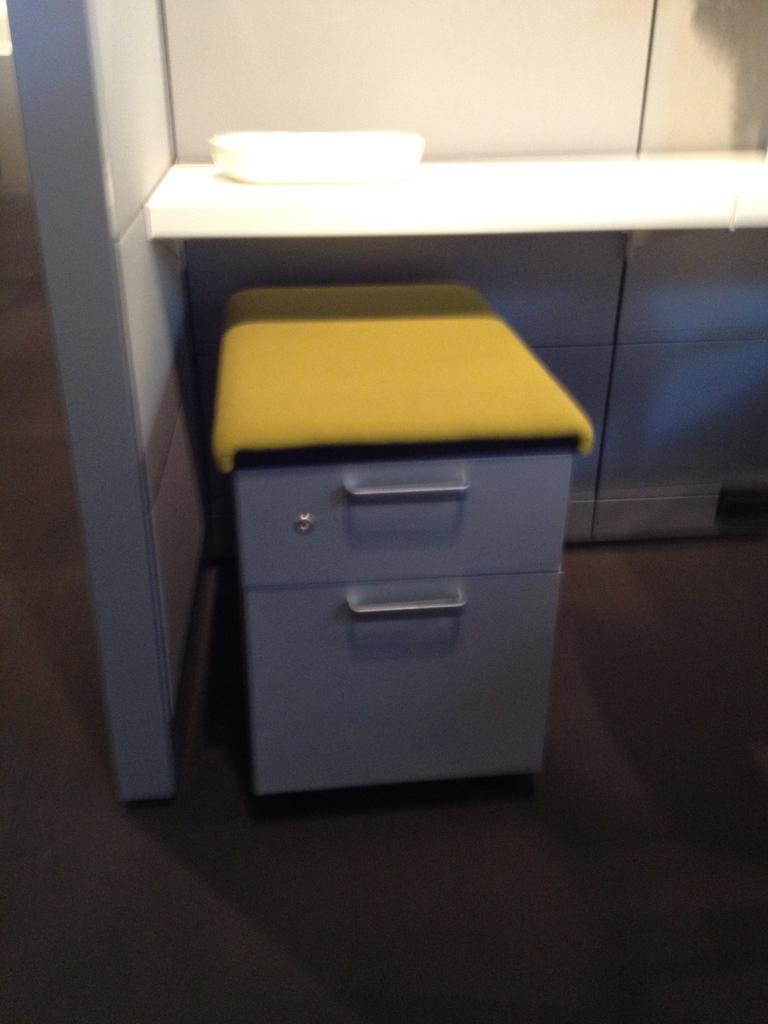What type of furniture is present in the image? There is a desk in the image. Where is the desk located in relation to other objects? The desk is near a table in the image. What is on the table? There is a box on the table. What is visible on the side of the desk? There is a wall beside the desk. What type of camp can be seen in the background of the image? There is no camp visible in the image; it only features a desk, a table, a box, and a wall. 